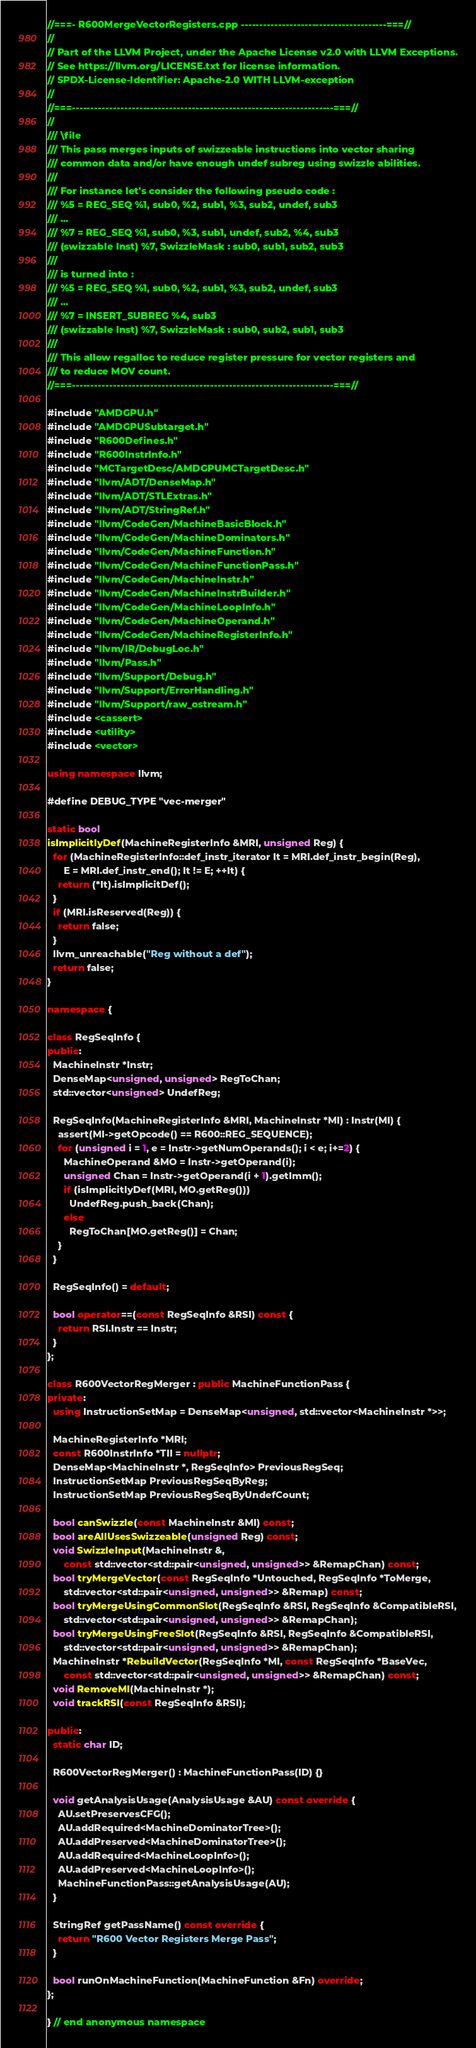<code> <loc_0><loc_0><loc_500><loc_500><_C++_>//===- R600MergeVectorRegisters.cpp ---------------------------------------===//
//
// Part of the LLVM Project, under the Apache License v2.0 with LLVM Exceptions.
// See https://llvm.org/LICENSE.txt for license information.
// SPDX-License-Identifier: Apache-2.0 WITH LLVM-exception
//
//===----------------------------------------------------------------------===//
//
/// \file
/// This pass merges inputs of swizzeable instructions into vector sharing
/// common data and/or have enough undef subreg using swizzle abilities.
///
/// For instance let's consider the following pseudo code :
/// %5 = REG_SEQ %1, sub0, %2, sub1, %3, sub2, undef, sub3
/// ...
/// %7 = REG_SEQ %1, sub0, %3, sub1, undef, sub2, %4, sub3
/// (swizzable Inst) %7, SwizzleMask : sub0, sub1, sub2, sub3
///
/// is turned into :
/// %5 = REG_SEQ %1, sub0, %2, sub1, %3, sub2, undef, sub3
/// ...
/// %7 = INSERT_SUBREG %4, sub3
/// (swizzable Inst) %7, SwizzleMask : sub0, sub2, sub1, sub3
///
/// This allow regalloc to reduce register pressure for vector registers and
/// to reduce MOV count.
//===----------------------------------------------------------------------===//

#include "AMDGPU.h"
#include "AMDGPUSubtarget.h"
#include "R600Defines.h"
#include "R600InstrInfo.h"
#include "MCTargetDesc/AMDGPUMCTargetDesc.h"
#include "llvm/ADT/DenseMap.h"
#include "llvm/ADT/STLExtras.h"
#include "llvm/ADT/StringRef.h"
#include "llvm/CodeGen/MachineBasicBlock.h"
#include "llvm/CodeGen/MachineDominators.h"
#include "llvm/CodeGen/MachineFunction.h"
#include "llvm/CodeGen/MachineFunctionPass.h"
#include "llvm/CodeGen/MachineInstr.h"
#include "llvm/CodeGen/MachineInstrBuilder.h"
#include "llvm/CodeGen/MachineLoopInfo.h"
#include "llvm/CodeGen/MachineOperand.h"
#include "llvm/CodeGen/MachineRegisterInfo.h"
#include "llvm/IR/DebugLoc.h"
#include "llvm/Pass.h"
#include "llvm/Support/Debug.h"
#include "llvm/Support/ErrorHandling.h"
#include "llvm/Support/raw_ostream.h"
#include <cassert>
#include <utility>
#include <vector>

using namespace llvm;

#define DEBUG_TYPE "vec-merger"

static bool
isImplicitlyDef(MachineRegisterInfo &MRI, unsigned Reg) {
  for (MachineRegisterInfo::def_instr_iterator It = MRI.def_instr_begin(Reg),
      E = MRI.def_instr_end(); It != E; ++It) {
    return (*It).isImplicitDef();
  }
  if (MRI.isReserved(Reg)) {
    return false;
  }
  llvm_unreachable("Reg without a def");
  return false;
}

namespace {

class RegSeqInfo {
public:
  MachineInstr *Instr;
  DenseMap<unsigned, unsigned> RegToChan;
  std::vector<unsigned> UndefReg;

  RegSeqInfo(MachineRegisterInfo &MRI, MachineInstr *MI) : Instr(MI) {
    assert(MI->getOpcode() == R600::REG_SEQUENCE);
    for (unsigned i = 1, e = Instr->getNumOperands(); i < e; i+=2) {
      MachineOperand &MO = Instr->getOperand(i);
      unsigned Chan = Instr->getOperand(i + 1).getImm();
      if (isImplicitlyDef(MRI, MO.getReg()))
        UndefReg.push_back(Chan);
      else
        RegToChan[MO.getReg()] = Chan;
    }
  }

  RegSeqInfo() = default;

  bool operator==(const RegSeqInfo &RSI) const {
    return RSI.Instr == Instr;
  }
};

class R600VectorRegMerger : public MachineFunctionPass {
private:
  using InstructionSetMap = DenseMap<unsigned, std::vector<MachineInstr *>>;

  MachineRegisterInfo *MRI;
  const R600InstrInfo *TII = nullptr;
  DenseMap<MachineInstr *, RegSeqInfo> PreviousRegSeq;
  InstructionSetMap PreviousRegSeqByReg;
  InstructionSetMap PreviousRegSeqByUndefCount;

  bool canSwizzle(const MachineInstr &MI) const;
  bool areAllUsesSwizzeable(unsigned Reg) const;
  void SwizzleInput(MachineInstr &,
      const std::vector<std::pair<unsigned, unsigned>> &RemapChan) const;
  bool tryMergeVector(const RegSeqInfo *Untouched, RegSeqInfo *ToMerge,
      std::vector<std::pair<unsigned, unsigned>> &Remap) const;
  bool tryMergeUsingCommonSlot(RegSeqInfo &RSI, RegSeqInfo &CompatibleRSI,
      std::vector<std::pair<unsigned, unsigned>> &RemapChan);
  bool tryMergeUsingFreeSlot(RegSeqInfo &RSI, RegSeqInfo &CompatibleRSI,
      std::vector<std::pair<unsigned, unsigned>> &RemapChan);
  MachineInstr *RebuildVector(RegSeqInfo *MI, const RegSeqInfo *BaseVec,
      const std::vector<std::pair<unsigned, unsigned>> &RemapChan) const;
  void RemoveMI(MachineInstr *);
  void trackRSI(const RegSeqInfo &RSI);

public:
  static char ID;

  R600VectorRegMerger() : MachineFunctionPass(ID) {}

  void getAnalysisUsage(AnalysisUsage &AU) const override {
    AU.setPreservesCFG();
    AU.addRequired<MachineDominatorTree>();
    AU.addPreserved<MachineDominatorTree>();
    AU.addRequired<MachineLoopInfo>();
    AU.addPreserved<MachineLoopInfo>();
    MachineFunctionPass::getAnalysisUsage(AU);
  }

  StringRef getPassName() const override {
    return "R600 Vector Registers Merge Pass";
  }

  bool runOnMachineFunction(MachineFunction &Fn) override;
};

} // end anonymous namespace
</code> 